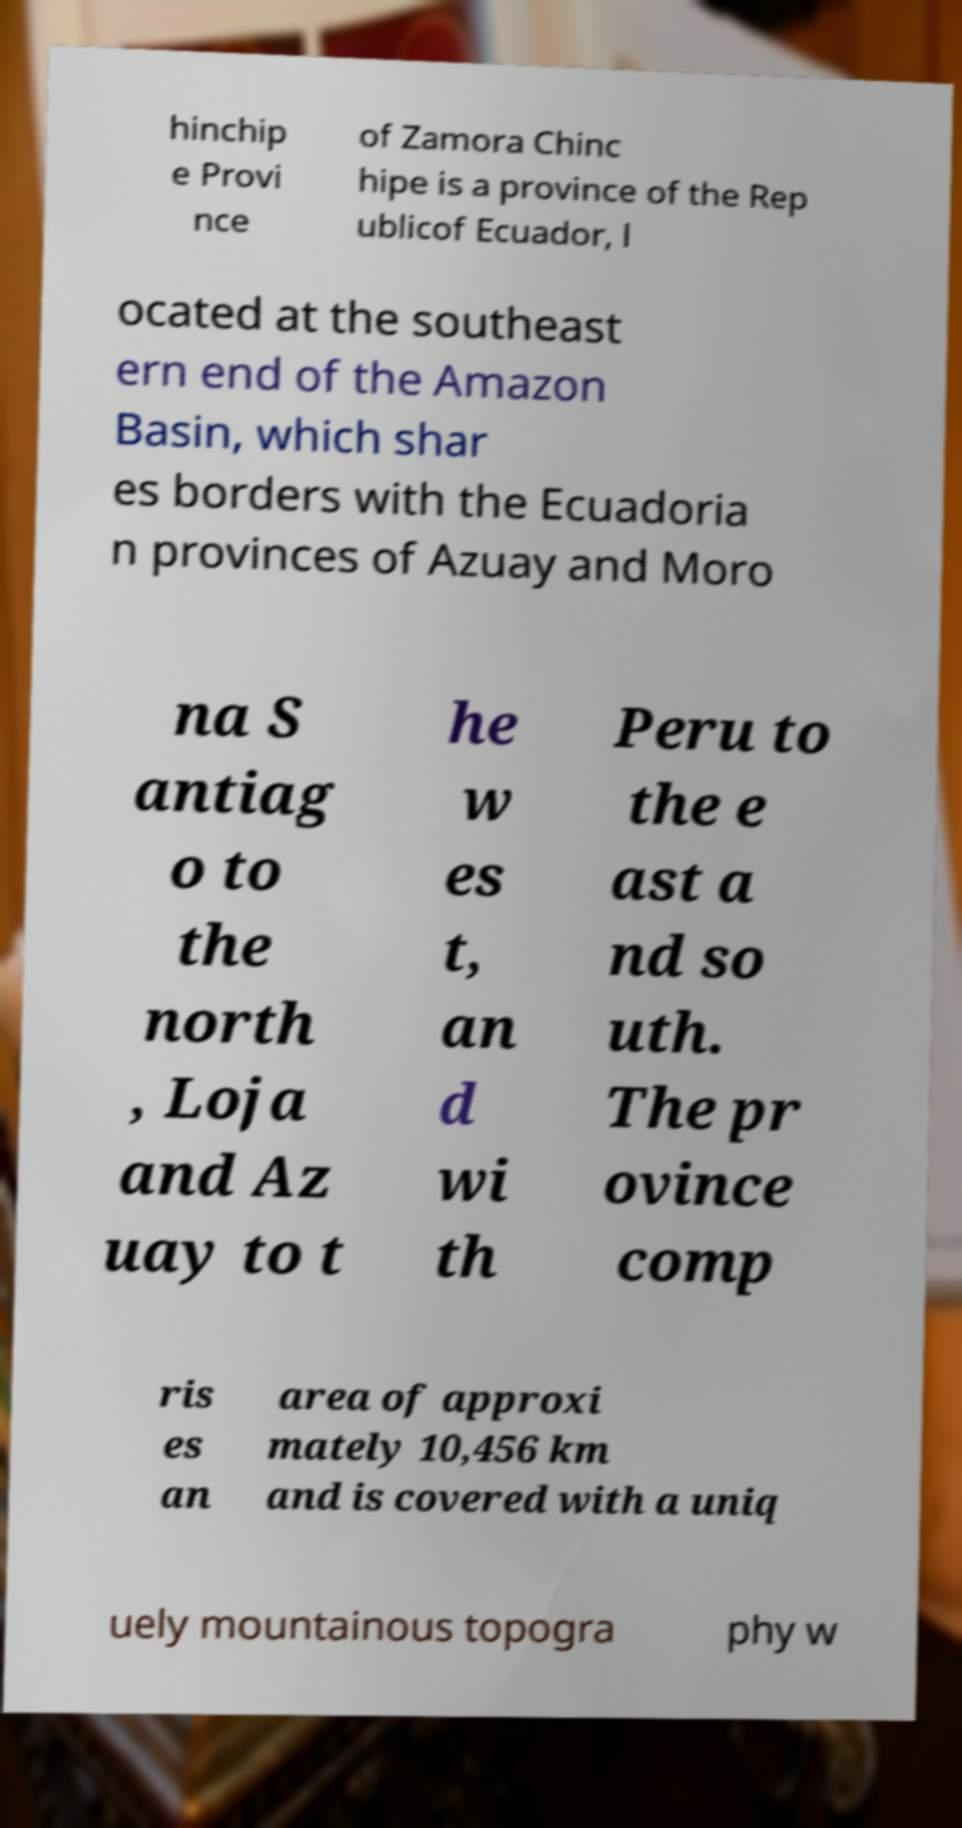There's text embedded in this image that I need extracted. Can you transcribe it verbatim? hinchip e Provi nce of Zamora Chinc hipe is a province of the Rep ublicof Ecuador, l ocated at the southeast ern end of the Amazon Basin, which shar es borders with the Ecuadoria n provinces of Azuay and Moro na S antiag o to the north , Loja and Az uay to t he w es t, an d wi th Peru to the e ast a nd so uth. The pr ovince comp ris es an area of approxi mately 10,456 km and is covered with a uniq uely mountainous topogra phy w 